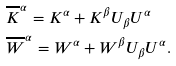Convert formula to latex. <formula><loc_0><loc_0><loc_500><loc_500>& \overline { K } ^ { \alpha } = K ^ { \alpha } + K ^ { \beta } U _ { \beta } U ^ { \alpha } \\ & \overline { W } ^ { \alpha } = W ^ { \alpha } + W ^ { \beta } U _ { \beta } U ^ { \alpha } .</formula> 